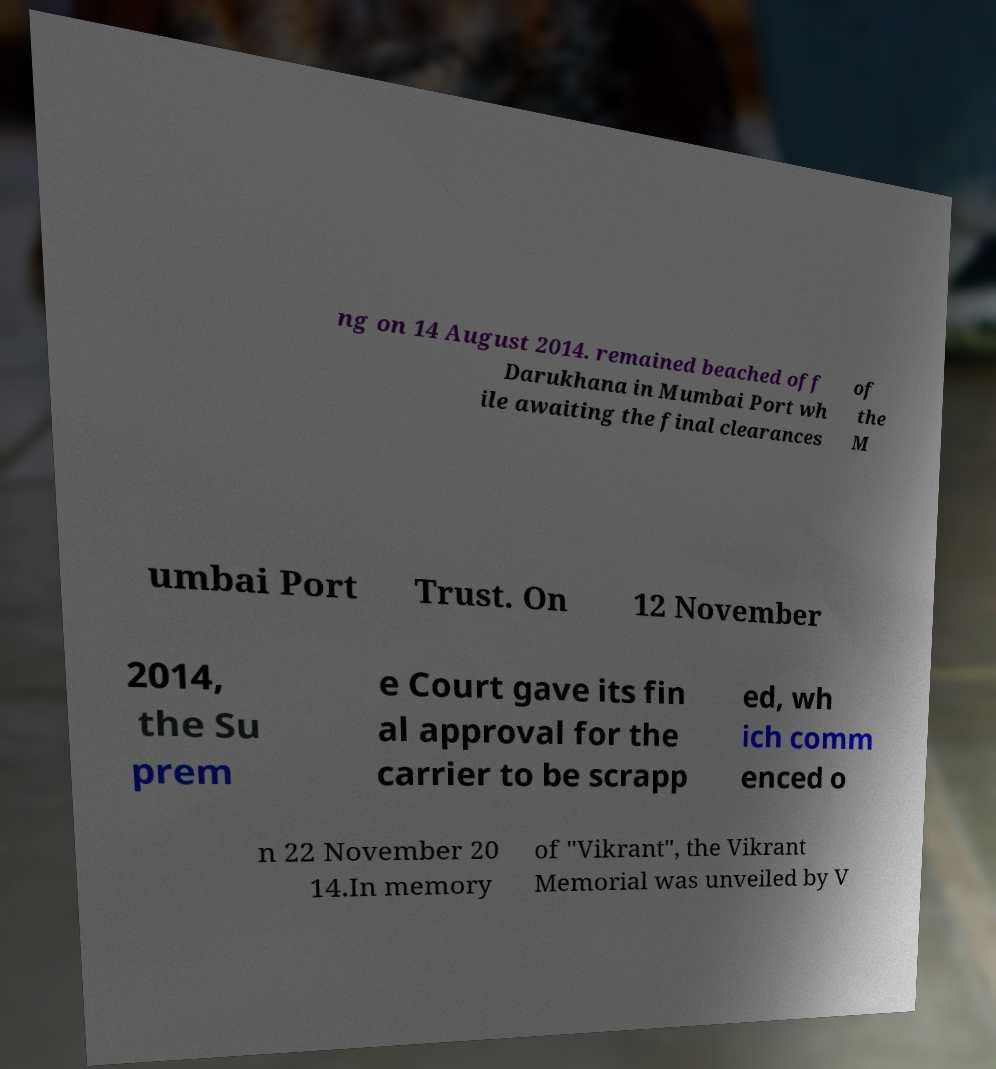Can you accurately transcribe the text from the provided image for me? ng on 14 August 2014. remained beached off Darukhana in Mumbai Port wh ile awaiting the final clearances of the M umbai Port Trust. On 12 November 2014, the Su prem e Court gave its fin al approval for the carrier to be scrapp ed, wh ich comm enced o n 22 November 20 14.In memory of "Vikrant", the Vikrant Memorial was unveiled by V 